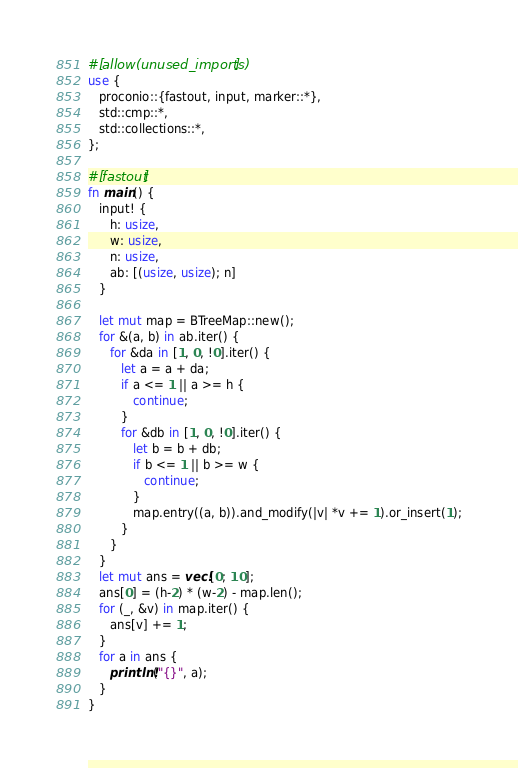Convert code to text. <code><loc_0><loc_0><loc_500><loc_500><_Rust_>#[allow(unused_imports)]
use {
   proconio::{fastout, input, marker::*},
   std::cmp::*,
   std::collections::*,
};

#[fastout]
fn main() {
   input! {
      h: usize,
      w: usize,
      n: usize,
      ab: [(usize, usize); n]
   }

   let mut map = BTreeMap::new();
   for &(a, b) in ab.iter() {
      for &da in [1, 0, !0].iter() {
         let a = a + da;
         if a <= 1 || a >= h {
            continue;
         }
         for &db in [1, 0, !0].iter() {
            let b = b + db;
            if b <= 1 || b >= w {
               continue;
            }
            map.entry((a, b)).and_modify(|v| *v += 1).or_insert(1);
         }
      }
   }
   let mut ans = vec![0; 10];
   ans[0] = (h-2) * (w-2) - map.len();
   for (_, &v) in map.iter() {
      ans[v] += 1;
   }
   for a in ans {
      println!("{}", a);
   }
}
</code> 